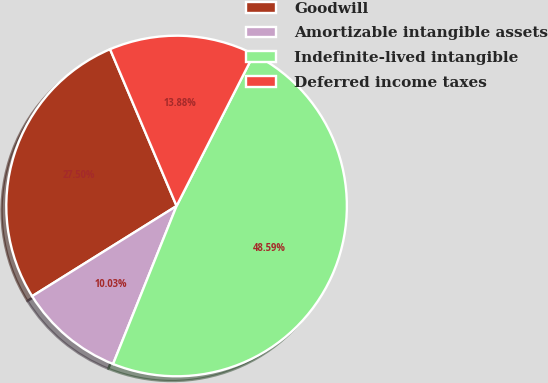Convert chart. <chart><loc_0><loc_0><loc_500><loc_500><pie_chart><fcel>Goodwill<fcel>Amortizable intangible assets<fcel>Indefinite-lived intangible<fcel>Deferred income taxes<nl><fcel>27.5%<fcel>10.03%<fcel>48.59%<fcel>13.88%<nl></chart> 